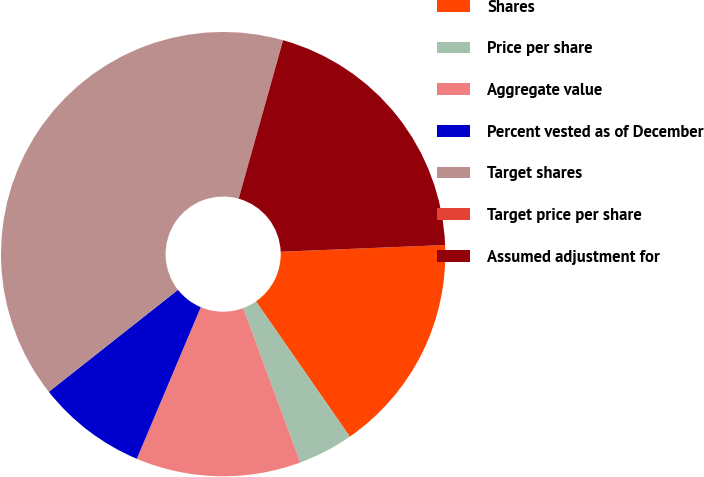Convert chart. <chart><loc_0><loc_0><loc_500><loc_500><pie_chart><fcel>Shares<fcel>Price per share<fcel>Aggregate value<fcel>Percent vested as of December<fcel>Target shares<fcel>Target price per share<fcel>Assumed adjustment for<nl><fcel>16.0%<fcel>4.01%<fcel>12.0%<fcel>8.01%<fcel>39.98%<fcel>0.01%<fcel>20.0%<nl></chart> 